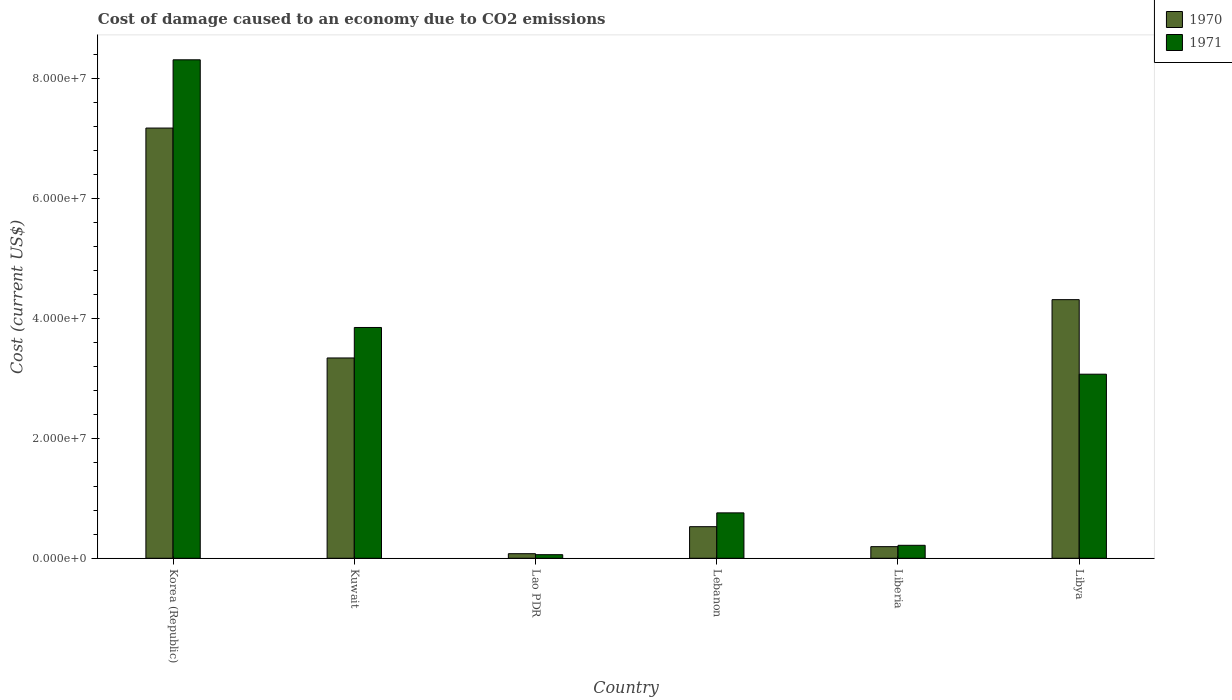How many different coloured bars are there?
Give a very brief answer. 2. Are the number of bars per tick equal to the number of legend labels?
Offer a very short reply. Yes. Are the number of bars on each tick of the X-axis equal?
Your response must be concise. Yes. How many bars are there on the 5th tick from the right?
Offer a terse response. 2. What is the label of the 5th group of bars from the left?
Keep it short and to the point. Liberia. What is the cost of damage caused due to CO2 emissisons in 1971 in Lao PDR?
Your answer should be very brief. 5.98e+05. Across all countries, what is the maximum cost of damage caused due to CO2 emissisons in 1970?
Provide a short and direct response. 7.18e+07. Across all countries, what is the minimum cost of damage caused due to CO2 emissisons in 1971?
Your answer should be very brief. 5.98e+05. In which country was the cost of damage caused due to CO2 emissisons in 1970 minimum?
Keep it short and to the point. Lao PDR. What is the total cost of damage caused due to CO2 emissisons in 1971 in the graph?
Offer a terse response. 1.63e+08. What is the difference between the cost of damage caused due to CO2 emissisons in 1970 in Korea (Republic) and that in Lao PDR?
Provide a short and direct response. 7.10e+07. What is the difference between the cost of damage caused due to CO2 emissisons in 1970 in Libya and the cost of damage caused due to CO2 emissisons in 1971 in Lao PDR?
Offer a terse response. 4.26e+07. What is the average cost of damage caused due to CO2 emissisons in 1971 per country?
Provide a succinct answer. 2.71e+07. What is the difference between the cost of damage caused due to CO2 emissisons of/in 1970 and cost of damage caused due to CO2 emissisons of/in 1971 in Lebanon?
Offer a terse response. -2.30e+06. In how many countries, is the cost of damage caused due to CO2 emissisons in 1970 greater than 60000000 US$?
Offer a terse response. 1. What is the ratio of the cost of damage caused due to CO2 emissisons in 1970 in Liberia to that in Libya?
Give a very brief answer. 0.04. Is the cost of damage caused due to CO2 emissisons in 1971 in Korea (Republic) less than that in Lao PDR?
Your answer should be very brief. No. What is the difference between the highest and the second highest cost of damage caused due to CO2 emissisons in 1971?
Ensure brevity in your answer.  5.25e+07. What is the difference between the highest and the lowest cost of damage caused due to CO2 emissisons in 1971?
Give a very brief answer. 8.26e+07. In how many countries, is the cost of damage caused due to CO2 emissisons in 1970 greater than the average cost of damage caused due to CO2 emissisons in 1970 taken over all countries?
Your response must be concise. 3. Is the sum of the cost of damage caused due to CO2 emissisons in 1970 in Lebanon and Liberia greater than the maximum cost of damage caused due to CO2 emissisons in 1971 across all countries?
Your response must be concise. No. How many bars are there?
Your answer should be very brief. 12. What is the difference between two consecutive major ticks on the Y-axis?
Your answer should be very brief. 2.00e+07. Are the values on the major ticks of Y-axis written in scientific E-notation?
Ensure brevity in your answer.  Yes. Does the graph contain grids?
Keep it short and to the point. No. Where does the legend appear in the graph?
Ensure brevity in your answer.  Top right. How are the legend labels stacked?
Ensure brevity in your answer.  Vertical. What is the title of the graph?
Your response must be concise. Cost of damage caused to an economy due to CO2 emissions. What is the label or title of the X-axis?
Keep it short and to the point. Country. What is the label or title of the Y-axis?
Provide a succinct answer. Cost (current US$). What is the Cost (current US$) of 1970 in Korea (Republic)?
Ensure brevity in your answer.  7.18e+07. What is the Cost (current US$) in 1971 in Korea (Republic)?
Your answer should be compact. 8.32e+07. What is the Cost (current US$) of 1970 in Kuwait?
Offer a very short reply. 3.34e+07. What is the Cost (current US$) in 1971 in Kuwait?
Ensure brevity in your answer.  3.85e+07. What is the Cost (current US$) in 1970 in Lao PDR?
Your answer should be compact. 7.64e+05. What is the Cost (current US$) of 1971 in Lao PDR?
Provide a short and direct response. 5.98e+05. What is the Cost (current US$) in 1970 in Lebanon?
Your answer should be compact. 5.27e+06. What is the Cost (current US$) of 1971 in Lebanon?
Your answer should be very brief. 7.58e+06. What is the Cost (current US$) in 1970 in Liberia?
Make the answer very short. 1.94e+06. What is the Cost (current US$) in 1971 in Liberia?
Give a very brief answer. 2.16e+06. What is the Cost (current US$) in 1970 in Libya?
Offer a terse response. 4.32e+07. What is the Cost (current US$) of 1971 in Libya?
Keep it short and to the point. 3.07e+07. Across all countries, what is the maximum Cost (current US$) of 1970?
Make the answer very short. 7.18e+07. Across all countries, what is the maximum Cost (current US$) of 1971?
Give a very brief answer. 8.32e+07. Across all countries, what is the minimum Cost (current US$) in 1970?
Your answer should be compact. 7.64e+05. Across all countries, what is the minimum Cost (current US$) in 1971?
Your response must be concise. 5.98e+05. What is the total Cost (current US$) in 1970 in the graph?
Your answer should be very brief. 1.56e+08. What is the total Cost (current US$) in 1971 in the graph?
Provide a succinct answer. 1.63e+08. What is the difference between the Cost (current US$) in 1970 in Korea (Republic) and that in Kuwait?
Your response must be concise. 3.84e+07. What is the difference between the Cost (current US$) of 1971 in Korea (Republic) and that in Kuwait?
Make the answer very short. 4.47e+07. What is the difference between the Cost (current US$) of 1970 in Korea (Republic) and that in Lao PDR?
Your response must be concise. 7.10e+07. What is the difference between the Cost (current US$) in 1971 in Korea (Republic) and that in Lao PDR?
Keep it short and to the point. 8.26e+07. What is the difference between the Cost (current US$) of 1970 in Korea (Republic) and that in Lebanon?
Offer a terse response. 6.65e+07. What is the difference between the Cost (current US$) in 1971 in Korea (Republic) and that in Lebanon?
Your answer should be compact. 7.56e+07. What is the difference between the Cost (current US$) of 1970 in Korea (Republic) and that in Liberia?
Give a very brief answer. 6.99e+07. What is the difference between the Cost (current US$) in 1971 in Korea (Republic) and that in Liberia?
Your answer should be compact. 8.10e+07. What is the difference between the Cost (current US$) in 1970 in Korea (Republic) and that in Libya?
Your answer should be very brief. 2.86e+07. What is the difference between the Cost (current US$) in 1971 in Korea (Republic) and that in Libya?
Offer a very short reply. 5.25e+07. What is the difference between the Cost (current US$) of 1970 in Kuwait and that in Lao PDR?
Provide a succinct answer. 3.27e+07. What is the difference between the Cost (current US$) of 1971 in Kuwait and that in Lao PDR?
Your answer should be very brief. 3.79e+07. What is the difference between the Cost (current US$) in 1970 in Kuwait and that in Lebanon?
Your response must be concise. 2.82e+07. What is the difference between the Cost (current US$) of 1971 in Kuwait and that in Lebanon?
Provide a succinct answer. 3.09e+07. What is the difference between the Cost (current US$) of 1970 in Kuwait and that in Liberia?
Your response must be concise. 3.15e+07. What is the difference between the Cost (current US$) in 1971 in Kuwait and that in Liberia?
Provide a succinct answer. 3.63e+07. What is the difference between the Cost (current US$) of 1970 in Kuwait and that in Libya?
Make the answer very short. -9.73e+06. What is the difference between the Cost (current US$) in 1971 in Kuwait and that in Libya?
Your answer should be compact. 7.80e+06. What is the difference between the Cost (current US$) in 1970 in Lao PDR and that in Lebanon?
Keep it short and to the point. -4.51e+06. What is the difference between the Cost (current US$) in 1971 in Lao PDR and that in Lebanon?
Offer a terse response. -6.98e+06. What is the difference between the Cost (current US$) in 1970 in Lao PDR and that in Liberia?
Ensure brevity in your answer.  -1.17e+06. What is the difference between the Cost (current US$) in 1971 in Lao PDR and that in Liberia?
Keep it short and to the point. -1.57e+06. What is the difference between the Cost (current US$) in 1970 in Lao PDR and that in Libya?
Make the answer very short. -4.24e+07. What is the difference between the Cost (current US$) in 1971 in Lao PDR and that in Libya?
Your response must be concise. -3.01e+07. What is the difference between the Cost (current US$) in 1970 in Lebanon and that in Liberia?
Your response must be concise. 3.33e+06. What is the difference between the Cost (current US$) in 1971 in Lebanon and that in Liberia?
Your answer should be compact. 5.41e+06. What is the difference between the Cost (current US$) of 1970 in Lebanon and that in Libya?
Provide a short and direct response. -3.79e+07. What is the difference between the Cost (current US$) of 1971 in Lebanon and that in Libya?
Your answer should be very brief. -2.31e+07. What is the difference between the Cost (current US$) in 1970 in Liberia and that in Libya?
Your response must be concise. -4.12e+07. What is the difference between the Cost (current US$) in 1971 in Liberia and that in Libya?
Offer a terse response. -2.86e+07. What is the difference between the Cost (current US$) of 1970 in Korea (Republic) and the Cost (current US$) of 1971 in Kuwait?
Provide a short and direct response. 3.33e+07. What is the difference between the Cost (current US$) in 1970 in Korea (Republic) and the Cost (current US$) in 1971 in Lao PDR?
Offer a terse response. 7.12e+07. What is the difference between the Cost (current US$) of 1970 in Korea (Republic) and the Cost (current US$) of 1971 in Lebanon?
Offer a very short reply. 6.42e+07. What is the difference between the Cost (current US$) of 1970 in Korea (Republic) and the Cost (current US$) of 1971 in Liberia?
Your response must be concise. 6.96e+07. What is the difference between the Cost (current US$) of 1970 in Korea (Republic) and the Cost (current US$) of 1971 in Libya?
Offer a terse response. 4.11e+07. What is the difference between the Cost (current US$) of 1970 in Kuwait and the Cost (current US$) of 1971 in Lao PDR?
Keep it short and to the point. 3.28e+07. What is the difference between the Cost (current US$) of 1970 in Kuwait and the Cost (current US$) of 1971 in Lebanon?
Ensure brevity in your answer.  2.58e+07. What is the difference between the Cost (current US$) in 1970 in Kuwait and the Cost (current US$) in 1971 in Liberia?
Give a very brief answer. 3.13e+07. What is the difference between the Cost (current US$) in 1970 in Kuwait and the Cost (current US$) in 1971 in Libya?
Ensure brevity in your answer.  2.71e+06. What is the difference between the Cost (current US$) of 1970 in Lao PDR and the Cost (current US$) of 1971 in Lebanon?
Offer a terse response. -6.81e+06. What is the difference between the Cost (current US$) in 1970 in Lao PDR and the Cost (current US$) in 1971 in Liberia?
Provide a succinct answer. -1.40e+06. What is the difference between the Cost (current US$) in 1970 in Lao PDR and the Cost (current US$) in 1971 in Libya?
Offer a very short reply. -3.00e+07. What is the difference between the Cost (current US$) of 1970 in Lebanon and the Cost (current US$) of 1971 in Liberia?
Offer a very short reply. 3.11e+06. What is the difference between the Cost (current US$) of 1970 in Lebanon and the Cost (current US$) of 1971 in Libya?
Make the answer very short. -2.54e+07. What is the difference between the Cost (current US$) in 1970 in Liberia and the Cost (current US$) in 1971 in Libya?
Your response must be concise. -2.88e+07. What is the average Cost (current US$) of 1970 per country?
Provide a succinct answer. 2.61e+07. What is the average Cost (current US$) in 1971 per country?
Your answer should be compact. 2.71e+07. What is the difference between the Cost (current US$) in 1970 and Cost (current US$) in 1971 in Korea (Republic)?
Offer a very short reply. -1.14e+07. What is the difference between the Cost (current US$) of 1970 and Cost (current US$) of 1971 in Kuwait?
Your answer should be compact. -5.09e+06. What is the difference between the Cost (current US$) in 1970 and Cost (current US$) in 1971 in Lao PDR?
Your answer should be compact. 1.65e+05. What is the difference between the Cost (current US$) in 1970 and Cost (current US$) in 1971 in Lebanon?
Ensure brevity in your answer.  -2.30e+06. What is the difference between the Cost (current US$) of 1970 and Cost (current US$) of 1971 in Liberia?
Your answer should be very brief. -2.26e+05. What is the difference between the Cost (current US$) in 1970 and Cost (current US$) in 1971 in Libya?
Give a very brief answer. 1.24e+07. What is the ratio of the Cost (current US$) of 1970 in Korea (Republic) to that in Kuwait?
Keep it short and to the point. 2.15. What is the ratio of the Cost (current US$) in 1971 in Korea (Republic) to that in Kuwait?
Make the answer very short. 2.16. What is the ratio of the Cost (current US$) in 1970 in Korea (Republic) to that in Lao PDR?
Ensure brevity in your answer.  94.02. What is the ratio of the Cost (current US$) of 1971 in Korea (Republic) to that in Lao PDR?
Provide a short and direct response. 139. What is the ratio of the Cost (current US$) of 1970 in Korea (Republic) to that in Lebanon?
Ensure brevity in your answer.  13.62. What is the ratio of the Cost (current US$) of 1971 in Korea (Republic) to that in Lebanon?
Provide a short and direct response. 10.98. What is the ratio of the Cost (current US$) of 1970 in Korea (Republic) to that in Liberia?
Make the answer very short. 37.04. What is the ratio of the Cost (current US$) of 1971 in Korea (Republic) to that in Liberia?
Your answer should be compact. 38.43. What is the ratio of the Cost (current US$) in 1970 in Korea (Republic) to that in Libya?
Your response must be concise. 1.66. What is the ratio of the Cost (current US$) in 1971 in Korea (Republic) to that in Libya?
Keep it short and to the point. 2.71. What is the ratio of the Cost (current US$) of 1970 in Kuwait to that in Lao PDR?
Give a very brief answer. 43.78. What is the ratio of the Cost (current US$) in 1971 in Kuwait to that in Lao PDR?
Keep it short and to the point. 64.36. What is the ratio of the Cost (current US$) in 1970 in Kuwait to that in Lebanon?
Your answer should be very brief. 6.34. What is the ratio of the Cost (current US$) in 1971 in Kuwait to that in Lebanon?
Give a very brief answer. 5.08. What is the ratio of the Cost (current US$) of 1970 in Kuwait to that in Liberia?
Provide a succinct answer. 17.24. What is the ratio of the Cost (current US$) in 1971 in Kuwait to that in Liberia?
Give a very brief answer. 17.79. What is the ratio of the Cost (current US$) of 1970 in Kuwait to that in Libya?
Ensure brevity in your answer.  0.77. What is the ratio of the Cost (current US$) of 1971 in Kuwait to that in Libya?
Ensure brevity in your answer.  1.25. What is the ratio of the Cost (current US$) in 1970 in Lao PDR to that in Lebanon?
Your answer should be compact. 0.14. What is the ratio of the Cost (current US$) of 1971 in Lao PDR to that in Lebanon?
Your answer should be compact. 0.08. What is the ratio of the Cost (current US$) of 1970 in Lao PDR to that in Liberia?
Ensure brevity in your answer.  0.39. What is the ratio of the Cost (current US$) of 1971 in Lao PDR to that in Liberia?
Your response must be concise. 0.28. What is the ratio of the Cost (current US$) in 1970 in Lao PDR to that in Libya?
Offer a terse response. 0.02. What is the ratio of the Cost (current US$) of 1971 in Lao PDR to that in Libya?
Make the answer very short. 0.02. What is the ratio of the Cost (current US$) of 1970 in Lebanon to that in Liberia?
Offer a terse response. 2.72. What is the ratio of the Cost (current US$) of 1970 in Lebanon to that in Libya?
Give a very brief answer. 0.12. What is the ratio of the Cost (current US$) in 1971 in Lebanon to that in Libya?
Make the answer very short. 0.25. What is the ratio of the Cost (current US$) in 1970 in Liberia to that in Libya?
Make the answer very short. 0.04. What is the ratio of the Cost (current US$) in 1971 in Liberia to that in Libya?
Offer a terse response. 0.07. What is the difference between the highest and the second highest Cost (current US$) of 1970?
Provide a short and direct response. 2.86e+07. What is the difference between the highest and the second highest Cost (current US$) in 1971?
Ensure brevity in your answer.  4.47e+07. What is the difference between the highest and the lowest Cost (current US$) of 1970?
Provide a short and direct response. 7.10e+07. What is the difference between the highest and the lowest Cost (current US$) of 1971?
Your answer should be compact. 8.26e+07. 